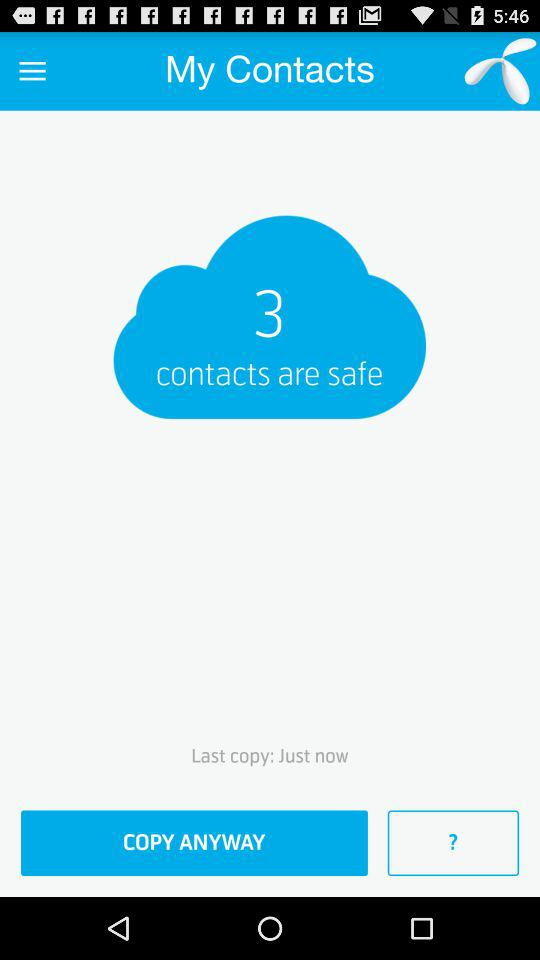How long ago was the last copy?
Answer the question using a single word or phrase. Just now 